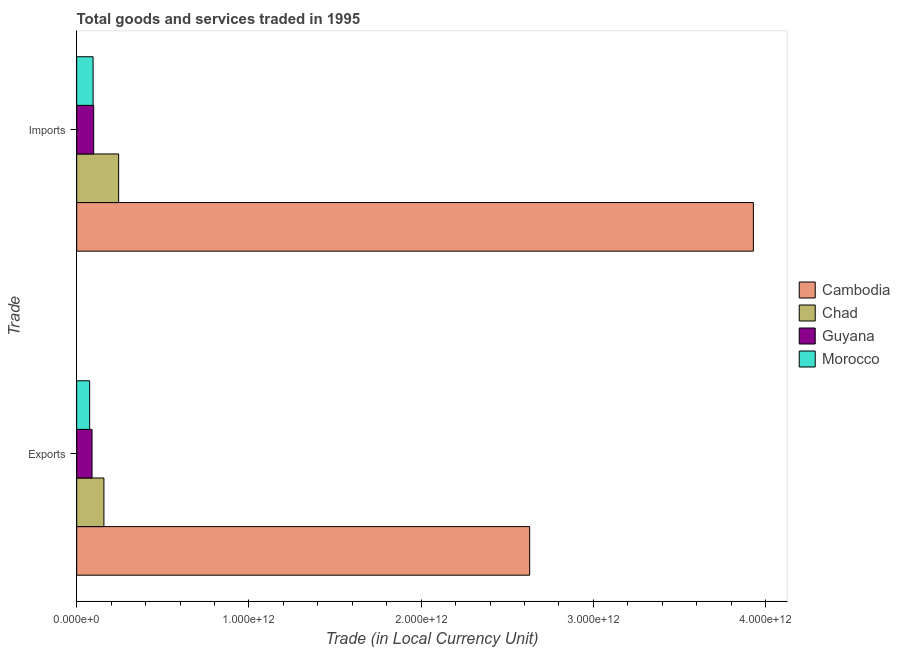How many different coloured bars are there?
Offer a very short reply. 4. Are the number of bars per tick equal to the number of legend labels?
Offer a terse response. Yes. What is the label of the 1st group of bars from the top?
Offer a terse response. Imports. What is the imports of goods and services in Chad?
Ensure brevity in your answer.  2.44e+11. Across all countries, what is the maximum export of goods and services?
Make the answer very short. 2.63e+12. Across all countries, what is the minimum export of goods and services?
Your answer should be compact. 7.55e+1. In which country was the imports of goods and services maximum?
Ensure brevity in your answer.  Cambodia. In which country was the imports of goods and services minimum?
Your response must be concise. Morocco. What is the total export of goods and services in the graph?
Your answer should be very brief. 2.95e+12. What is the difference between the export of goods and services in Cambodia and that in Morocco?
Provide a short and direct response. 2.55e+12. What is the difference between the export of goods and services in Guyana and the imports of goods and services in Morocco?
Give a very brief answer. -6.09e+09. What is the average imports of goods and services per country?
Your answer should be compact. 1.09e+12. What is the difference between the imports of goods and services and export of goods and services in Guyana?
Make the answer very short. 9.63e+09. In how many countries, is the export of goods and services greater than 3400000000000 LCU?
Offer a very short reply. 0. What is the ratio of the imports of goods and services in Guyana to that in Cambodia?
Make the answer very short. 0.03. Is the export of goods and services in Morocco less than that in Guyana?
Offer a very short reply. Yes. In how many countries, is the export of goods and services greater than the average export of goods and services taken over all countries?
Provide a short and direct response. 1. What does the 1st bar from the top in Imports represents?
Give a very brief answer. Morocco. What does the 2nd bar from the bottom in Exports represents?
Your response must be concise. Chad. Are all the bars in the graph horizontal?
Offer a very short reply. Yes. What is the difference between two consecutive major ticks on the X-axis?
Offer a terse response. 1.00e+12. Does the graph contain any zero values?
Provide a succinct answer. No. Does the graph contain grids?
Offer a very short reply. No. How are the legend labels stacked?
Keep it short and to the point. Vertical. What is the title of the graph?
Your answer should be very brief. Total goods and services traded in 1995. What is the label or title of the X-axis?
Offer a very short reply. Trade (in Local Currency Unit). What is the label or title of the Y-axis?
Your answer should be very brief. Trade. What is the Trade (in Local Currency Unit) in Cambodia in Exports?
Offer a terse response. 2.63e+12. What is the Trade (in Local Currency Unit) in Chad in Exports?
Make the answer very short. 1.58e+11. What is the Trade (in Local Currency Unit) of Guyana in Exports?
Keep it short and to the point. 8.93e+1. What is the Trade (in Local Currency Unit) in Morocco in Exports?
Your response must be concise. 7.55e+1. What is the Trade (in Local Currency Unit) of Cambodia in Imports?
Make the answer very short. 3.93e+12. What is the Trade (in Local Currency Unit) in Chad in Imports?
Provide a short and direct response. 2.44e+11. What is the Trade (in Local Currency Unit) in Guyana in Imports?
Offer a terse response. 9.90e+1. What is the Trade (in Local Currency Unit) of Morocco in Imports?
Provide a succinct answer. 9.54e+1. Across all Trade, what is the maximum Trade (in Local Currency Unit) of Cambodia?
Ensure brevity in your answer.  3.93e+12. Across all Trade, what is the maximum Trade (in Local Currency Unit) in Chad?
Your answer should be compact. 2.44e+11. Across all Trade, what is the maximum Trade (in Local Currency Unit) in Guyana?
Ensure brevity in your answer.  9.90e+1. Across all Trade, what is the maximum Trade (in Local Currency Unit) in Morocco?
Offer a very short reply. 9.54e+1. Across all Trade, what is the minimum Trade (in Local Currency Unit) of Cambodia?
Your response must be concise. 2.63e+12. Across all Trade, what is the minimum Trade (in Local Currency Unit) in Chad?
Provide a succinct answer. 1.58e+11. Across all Trade, what is the minimum Trade (in Local Currency Unit) of Guyana?
Make the answer very short. 8.93e+1. Across all Trade, what is the minimum Trade (in Local Currency Unit) of Morocco?
Make the answer very short. 7.55e+1. What is the total Trade (in Local Currency Unit) of Cambodia in the graph?
Keep it short and to the point. 6.56e+12. What is the total Trade (in Local Currency Unit) in Chad in the graph?
Provide a short and direct response. 4.02e+11. What is the total Trade (in Local Currency Unit) of Guyana in the graph?
Your response must be concise. 1.88e+11. What is the total Trade (in Local Currency Unit) of Morocco in the graph?
Provide a short and direct response. 1.71e+11. What is the difference between the Trade (in Local Currency Unit) of Cambodia in Exports and that in Imports?
Your response must be concise. -1.30e+12. What is the difference between the Trade (in Local Currency Unit) of Chad in Exports and that in Imports?
Make the answer very short. -8.54e+1. What is the difference between the Trade (in Local Currency Unit) of Guyana in Exports and that in Imports?
Ensure brevity in your answer.  -9.63e+09. What is the difference between the Trade (in Local Currency Unit) of Morocco in Exports and that in Imports?
Your response must be concise. -2.00e+1. What is the difference between the Trade (in Local Currency Unit) in Cambodia in Exports and the Trade (in Local Currency Unit) in Chad in Imports?
Your response must be concise. 2.39e+12. What is the difference between the Trade (in Local Currency Unit) in Cambodia in Exports and the Trade (in Local Currency Unit) in Guyana in Imports?
Keep it short and to the point. 2.53e+12. What is the difference between the Trade (in Local Currency Unit) in Cambodia in Exports and the Trade (in Local Currency Unit) in Morocco in Imports?
Offer a terse response. 2.53e+12. What is the difference between the Trade (in Local Currency Unit) of Chad in Exports and the Trade (in Local Currency Unit) of Guyana in Imports?
Your answer should be compact. 5.93e+1. What is the difference between the Trade (in Local Currency Unit) of Chad in Exports and the Trade (in Local Currency Unit) of Morocco in Imports?
Offer a terse response. 6.28e+1. What is the difference between the Trade (in Local Currency Unit) of Guyana in Exports and the Trade (in Local Currency Unit) of Morocco in Imports?
Your response must be concise. -6.09e+09. What is the average Trade (in Local Currency Unit) of Cambodia per Trade?
Make the answer very short. 3.28e+12. What is the average Trade (in Local Currency Unit) of Chad per Trade?
Ensure brevity in your answer.  2.01e+11. What is the average Trade (in Local Currency Unit) of Guyana per Trade?
Provide a succinct answer. 9.42e+1. What is the average Trade (in Local Currency Unit) in Morocco per Trade?
Offer a very short reply. 8.54e+1. What is the difference between the Trade (in Local Currency Unit) in Cambodia and Trade (in Local Currency Unit) in Chad in Exports?
Keep it short and to the point. 2.47e+12. What is the difference between the Trade (in Local Currency Unit) of Cambodia and Trade (in Local Currency Unit) of Guyana in Exports?
Make the answer very short. 2.54e+12. What is the difference between the Trade (in Local Currency Unit) in Cambodia and Trade (in Local Currency Unit) in Morocco in Exports?
Provide a short and direct response. 2.55e+12. What is the difference between the Trade (in Local Currency Unit) of Chad and Trade (in Local Currency Unit) of Guyana in Exports?
Your answer should be compact. 6.89e+1. What is the difference between the Trade (in Local Currency Unit) in Chad and Trade (in Local Currency Unit) in Morocco in Exports?
Provide a succinct answer. 8.28e+1. What is the difference between the Trade (in Local Currency Unit) of Guyana and Trade (in Local Currency Unit) of Morocco in Exports?
Make the answer very short. 1.39e+1. What is the difference between the Trade (in Local Currency Unit) in Cambodia and Trade (in Local Currency Unit) in Chad in Imports?
Offer a terse response. 3.68e+12. What is the difference between the Trade (in Local Currency Unit) in Cambodia and Trade (in Local Currency Unit) in Guyana in Imports?
Give a very brief answer. 3.83e+12. What is the difference between the Trade (in Local Currency Unit) in Cambodia and Trade (in Local Currency Unit) in Morocco in Imports?
Offer a terse response. 3.83e+12. What is the difference between the Trade (in Local Currency Unit) of Chad and Trade (in Local Currency Unit) of Guyana in Imports?
Give a very brief answer. 1.45e+11. What is the difference between the Trade (in Local Currency Unit) in Chad and Trade (in Local Currency Unit) in Morocco in Imports?
Provide a succinct answer. 1.48e+11. What is the difference between the Trade (in Local Currency Unit) in Guyana and Trade (in Local Currency Unit) in Morocco in Imports?
Your response must be concise. 3.53e+09. What is the ratio of the Trade (in Local Currency Unit) in Cambodia in Exports to that in Imports?
Ensure brevity in your answer.  0.67. What is the ratio of the Trade (in Local Currency Unit) in Chad in Exports to that in Imports?
Offer a very short reply. 0.65. What is the ratio of the Trade (in Local Currency Unit) in Guyana in Exports to that in Imports?
Keep it short and to the point. 0.9. What is the ratio of the Trade (in Local Currency Unit) in Morocco in Exports to that in Imports?
Your answer should be very brief. 0.79. What is the difference between the highest and the second highest Trade (in Local Currency Unit) of Cambodia?
Provide a short and direct response. 1.30e+12. What is the difference between the highest and the second highest Trade (in Local Currency Unit) in Chad?
Your answer should be compact. 8.54e+1. What is the difference between the highest and the second highest Trade (in Local Currency Unit) in Guyana?
Provide a short and direct response. 9.63e+09. What is the difference between the highest and the second highest Trade (in Local Currency Unit) of Morocco?
Offer a terse response. 2.00e+1. What is the difference between the highest and the lowest Trade (in Local Currency Unit) of Cambodia?
Give a very brief answer. 1.30e+12. What is the difference between the highest and the lowest Trade (in Local Currency Unit) of Chad?
Keep it short and to the point. 8.54e+1. What is the difference between the highest and the lowest Trade (in Local Currency Unit) in Guyana?
Give a very brief answer. 9.63e+09. What is the difference between the highest and the lowest Trade (in Local Currency Unit) of Morocco?
Provide a succinct answer. 2.00e+1. 